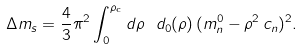Convert formula to latex. <formula><loc_0><loc_0><loc_500><loc_500>\Delta m _ { s } = \frac { 4 } { 3 } \pi ^ { 2 } \int _ { 0 } ^ { \rho _ { \text {c} } } d \rho \ d _ { 0 } ( \rho ) \, ( m _ { n } ^ { 0 } - \rho ^ { 2 } \, c _ { n } ) ^ { 2 } .</formula> 